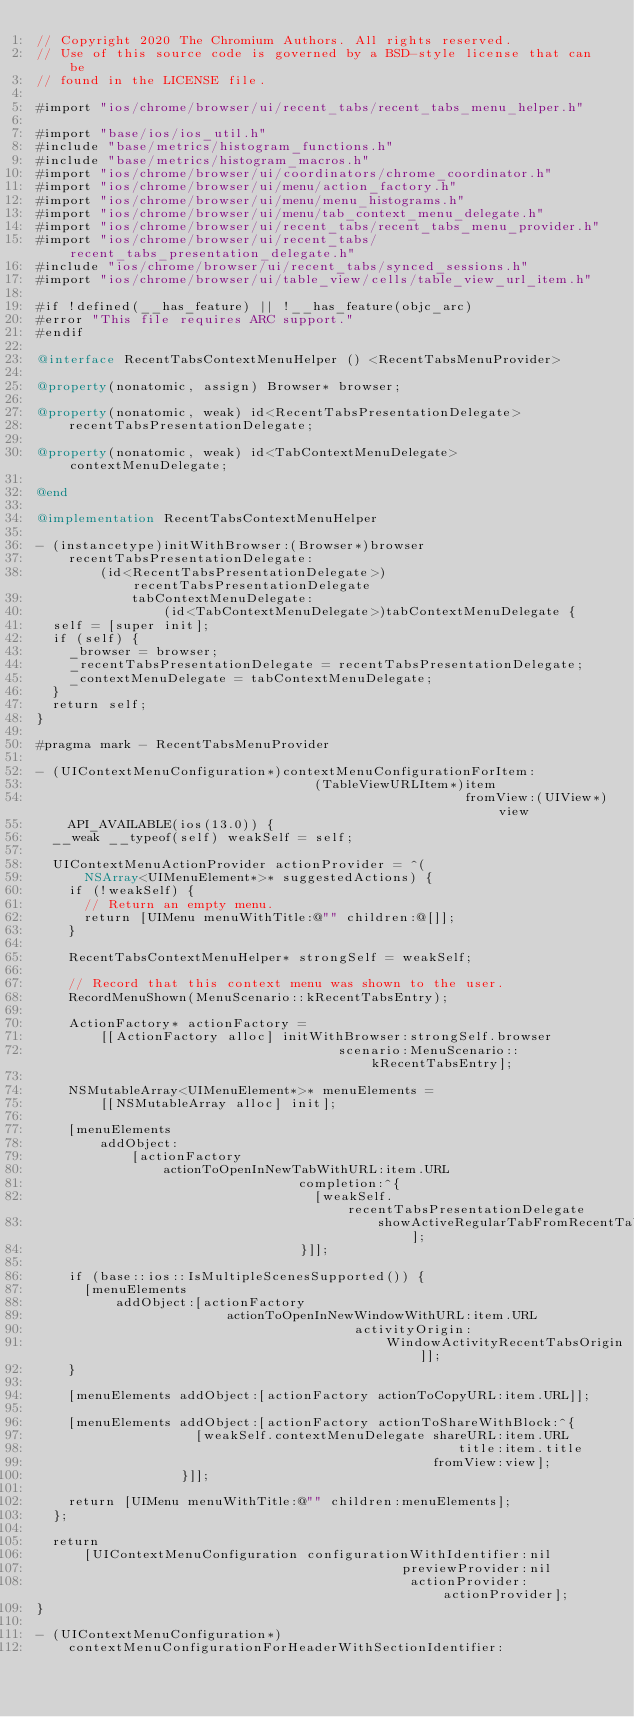<code> <loc_0><loc_0><loc_500><loc_500><_ObjectiveC_>// Copyright 2020 The Chromium Authors. All rights reserved.
// Use of this source code is governed by a BSD-style license that can be
// found in the LICENSE file.

#import "ios/chrome/browser/ui/recent_tabs/recent_tabs_menu_helper.h"

#import "base/ios/ios_util.h"
#include "base/metrics/histogram_functions.h"
#include "base/metrics/histogram_macros.h"
#import "ios/chrome/browser/ui/coordinators/chrome_coordinator.h"
#import "ios/chrome/browser/ui/menu/action_factory.h"
#import "ios/chrome/browser/ui/menu/menu_histograms.h"
#import "ios/chrome/browser/ui/menu/tab_context_menu_delegate.h"
#import "ios/chrome/browser/ui/recent_tabs/recent_tabs_menu_provider.h"
#import "ios/chrome/browser/ui/recent_tabs/recent_tabs_presentation_delegate.h"
#include "ios/chrome/browser/ui/recent_tabs/synced_sessions.h"
#import "ios/chrome/browser/ui/table_view/cells/table_view_url_item.h"

#if !defined(__has_feature) || !__has_feature(objc_arc)
#error "This file requires ARC support."
#endif

@interface RecentTabsContextMenuHelper () <RecentTabsMenuProvider>

@property(nonatomic, assign) Browser* browser;

@property(nonatomic, weak) id<RecentTabsPresentationDelegate>
    recentTabsPresentationDelegate;

@property(nonatomic, weak) id<TabContextMenuDelegate> contextMenuDelegate;

@end

@implementation RecentTabsContextMenuHelper

- (instancetype)initWithBrowser:(Browser*)browser
    recentTabsPresentationDelegate:
        (id<RecentTabsPresentationDelegate>)recentTabsPresentationDelegate
            tabContextMenuDelegate:
                (id<TabContextMenuDelegate>)tabContextMenuDelegate {
  self = [super init];
  if (self) {
    _browser = browser;
    _recentTabsPresentationDelegate = recentTabsPresentationDelegate;
    _contextMenuDelegate = tabContextMenuDelegate;
  }
  return self;
}

#pragma mark - RecentTabsMenuProvider

- (UIContextMenuConfiguration*)contextMenuConfigurationForItem:
                                   (TableViewURLItem*)item
                                                      fromView:(UIView*)view
    API_AVAILABLE(ios(13.0)) {
  __weak __typeof(self) weakSelf = self;

  UIContextMenuActionProvider actionProvider = ^(
      NSArray<UIMenuElement*>* suggestedActions) {
    if (!weakSelf) {
      // Return an empty menu.
      return [UIMenu menuWithTitle:@"" children:@[]];
    }

    RecentTabsContextMenuHelper* strongSelf = weakSelf;

    // Record that this context menu was shown to the user.
    RecordMenuShown(MenuScenario::kRecentTabsEntry);

    ActionFactory* actionFactory =
        [[ActionFactory alloc] initWithBrowser:strongSelf.browser
                                      scenario:MenuScenario::kRecentTabsEntry];

    NSMutableArray<UIMenuElement*>* menuElements =
        [[NSMutableArray alloc] init];

    [menuElements
        addObject:
            [actionFactory
                actionToOpenInNewTabWithURL:item.URL
                                 completion:^{
                                   [weakSelf.recentTabsPresentationDelegate
                                           showActiveRegularTabFromRecentTabs];
                                 }]];

    if (base::ios::IsMultipleScenesSupported()) {
      [menuElements
          addObject:[actionFactory
                        actionToOpenInNewWindowWithURL:item.URL
                                        activityOrigin:
                                            WindowActivityRecentTabsOrigin]];
    }

    [menuElements addObject:[actionFactory actionToCopyURL:item.URL]];

    [menuElements addObject:[actionFactory actionToShareWithBlock:^{
                    [weakSelf.contextMenuDelegate shareURL:item.URL
                                                     title:item.title
                                                  fromView:view];
                  }]];

    return [UIMenu menuWithTitle:@"" children:menuElements];
  };

  return
      [UIContextMenuConfiguration configurationWithIdentifier:nil
                                              previewProvider:nil
                                               actionProvider:actionProvider];
}

- (UIContextMenuConfiguration*)
    contextMenuConfigurationForHeaderWithSectionIdentifier:</code> 